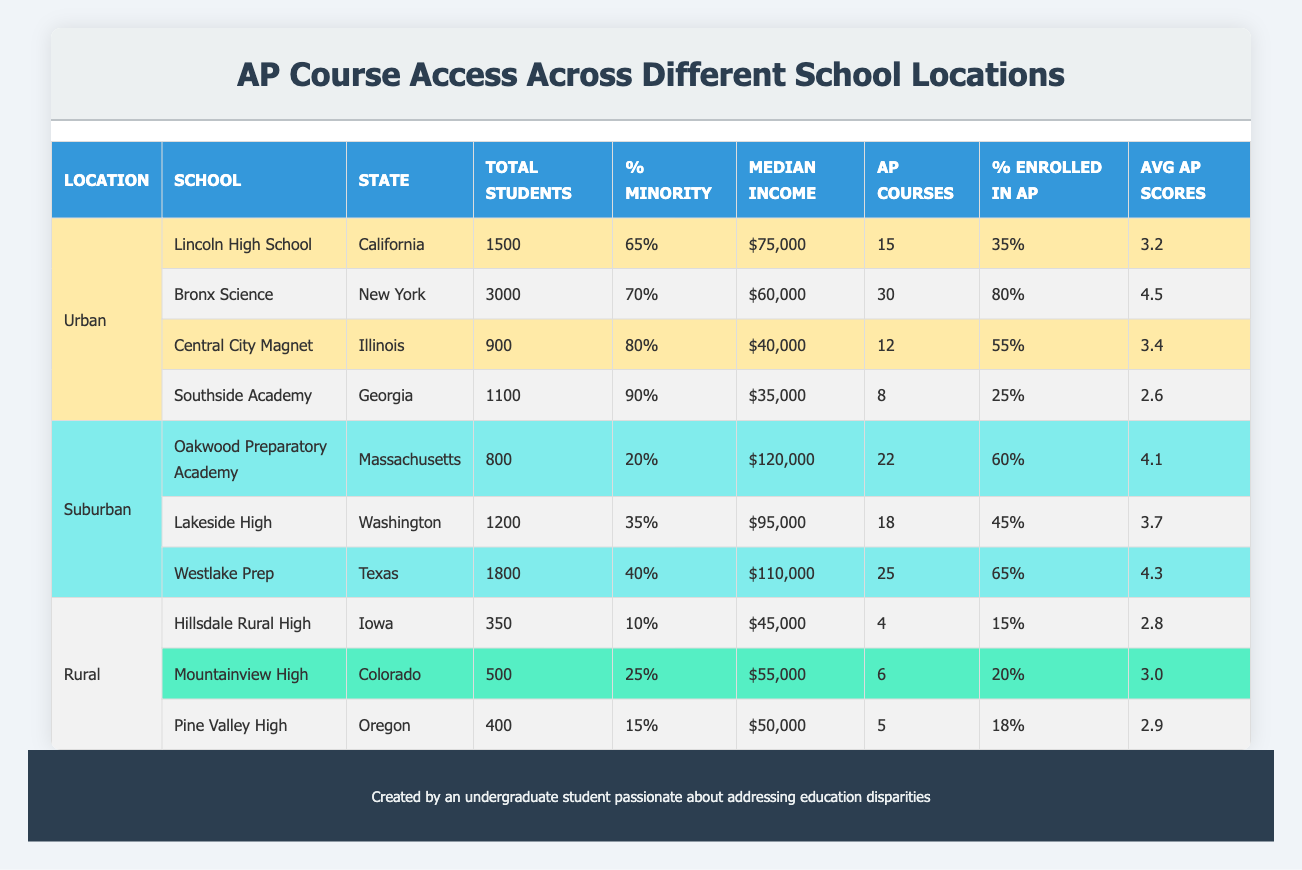What is the median income for students at Oakwood Preparatory Academy? The table lists the median income for Oakwood Preparatory Academy as $120,000.
Answer: $120,000 How many Advanced Placement courses are offered at Bronx Science? According to the table, Bronx Science offers 30 Advanced Placement courses.
Answer: 30 Is the percentage of minority students at Central City Magnet greater than 75%? The table shows that Central City Magnet has a percentage of minority students at 80%, which is greater than 75%.
Answer: Yes What is the difference in average AP scores between Westlake Prep and Southside Academy? Westlake Prep has an average AP score of 4.3, while Southside Academy has an average AP score of 2.6. The difference is 4.3 - 2.6 = 1.7.
Answer: 1.7 Which location has the highest percentage of students enrolled in AP courses? Bronx Science has the highest percentage of students enrolled in AP courses at 80%.
Answer: 80% What is the average number of AP courses offered in rural schools? The rural schools listed are Hillsdale Rural High (4), Mountainview High (6), and Pine Valley High (5). The average is (4 + 6 + 5) / 3 = 15/3 = 5.
Answer: 5 Do urban schools generally have a higher number of Advanced Placement courses than rural schools? Comparing the urban (actual numbers vary) and rural schools (4, 6, 5), we can see that Bronx Science has 30 AP courses, Central City Magnet has 12, and others have higher than rural schools. Therefore, urban schools tend to have more AP courses.
Answer: Yes How many total students are enrolled in Lakeside High School and Westlake Prep combined? Lakeside High has 1200 students, and Westlake Prep has 1800 students. The total is 1200 + 1800 = 3000.
Answer: 3000 Which school has the lowest percentage of students enrolled in Advanced Placement courses? Southside Academy has the lowest percentage of students enrolled in AP courses, at 25%.
Answer: 25 